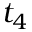<formula> <loc_0><loc_0><loc_500><loc_500>t _ { 4 }</formula> 